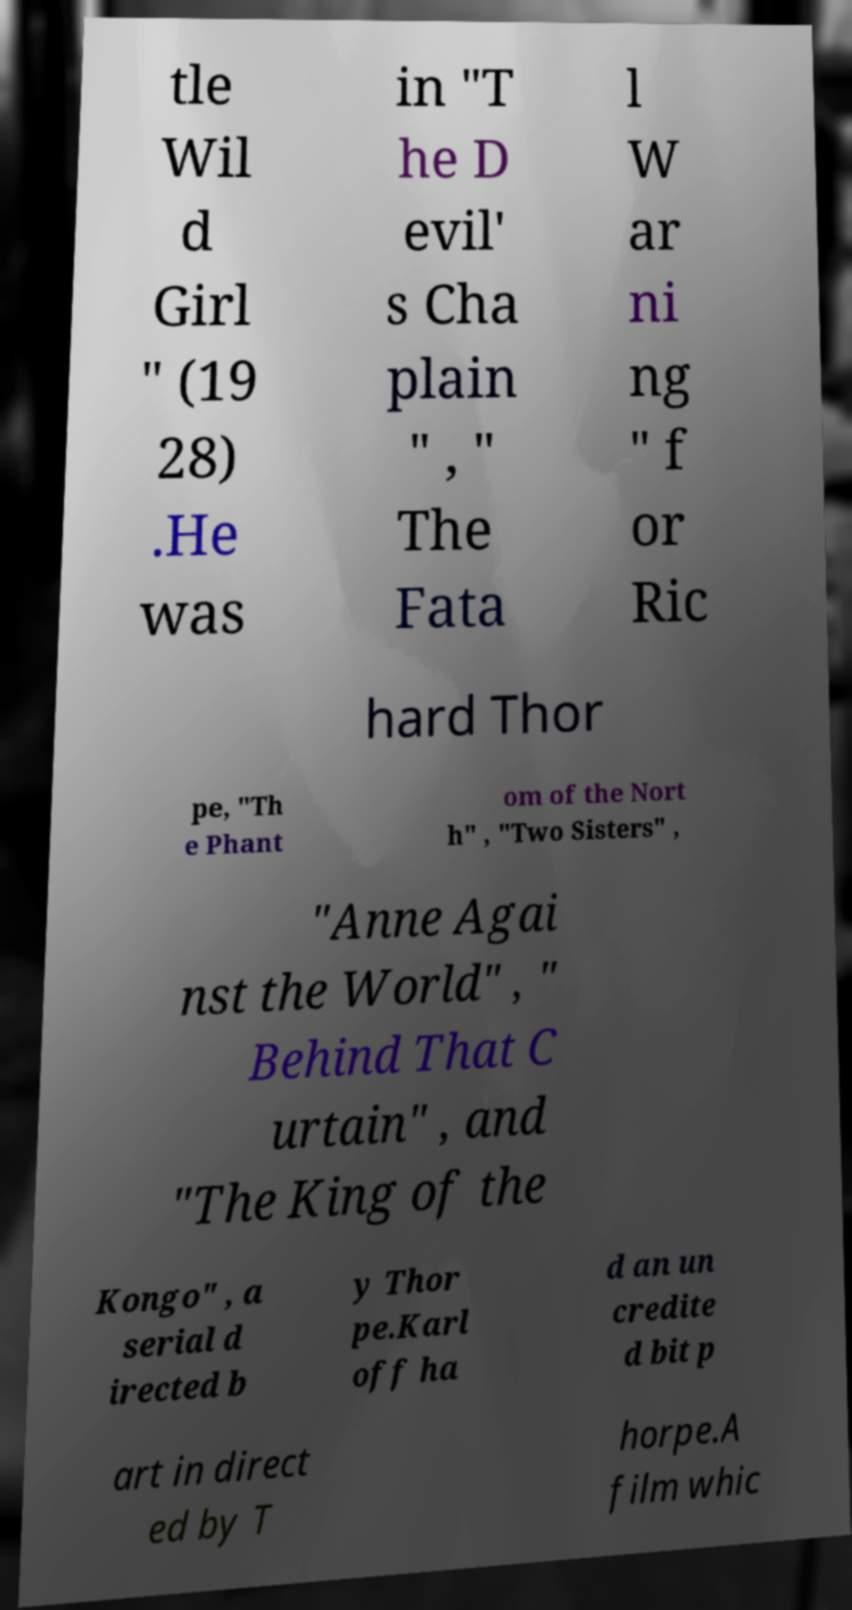What messages or text are displayed in this image? I need them in a readable, typed format. tle Wil d Girl " (19 28) .He was in "T he D evil' s Cha plain " , " The Fata l W ar ni ng " f or Ric hard Thor pe, "Th e Phant om of the Nort h" , "Two Sisters" , "Anne Agai nst the World" , " Behind That C urtain" , and "The King of the Kongo" , a serial d irected b y Thor pe.Karl off ha d an un credite d bit p art in direct ed by T horpe.A film whic 